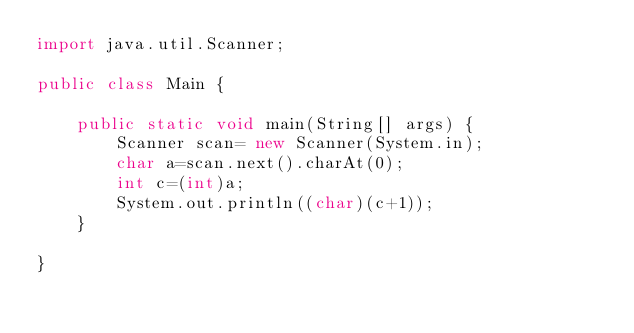Convert code to text. <code><loc_0><loc_0><loc_500><loc_500><_Java_>import java.util.Scanner;

public class Main {

	public static void main(String[] args) {
		Scanner scan= new Scanner(System.in);
		char a=scan.next().charAt(0);
		int c=(int)a;
		System.out.println((char)(c+1));
	}

}
</code> 